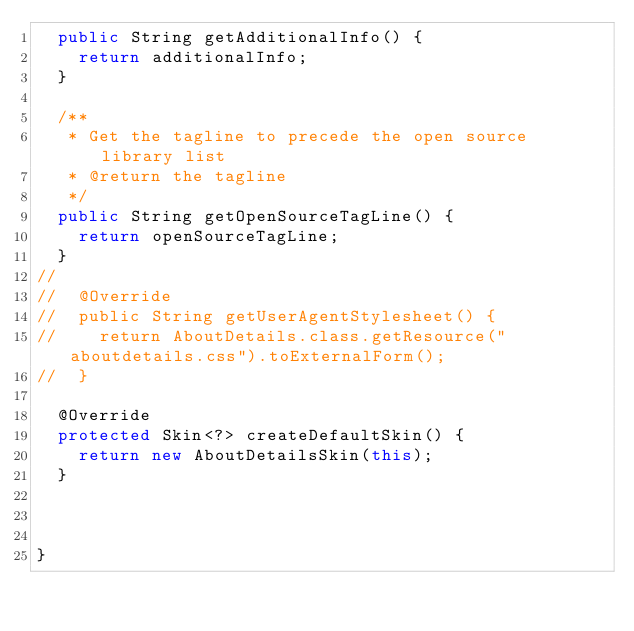Convert code to text. <code><loc_0><loc_0><loc_500><loc_500><_Java_>	public String getAdditionalInfo() {
		return additionalInfo;
	}

	/**
	 * Get the tagline to precede the open source library list
	 * @return the tagline
	 */
	public String getOpenSourceTagLine() {
		return openSourceTagLine;
	}
//
//	@Override
//	public String getUserAgentStylesheet() {
//		return AboutDetails.class.getResource("aboutdetails.css").toExternalForm();
//	}

	@Override
	protected Skin<?> createDefaultSkin() {
		return new AboutDetailsSkin(this);
	}



}
</code> 